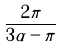<formula> <loc_0><loc_0><loc_500><loc_500>\frac { 2 \pi } { 3 \alpha - \pi }</formula> 